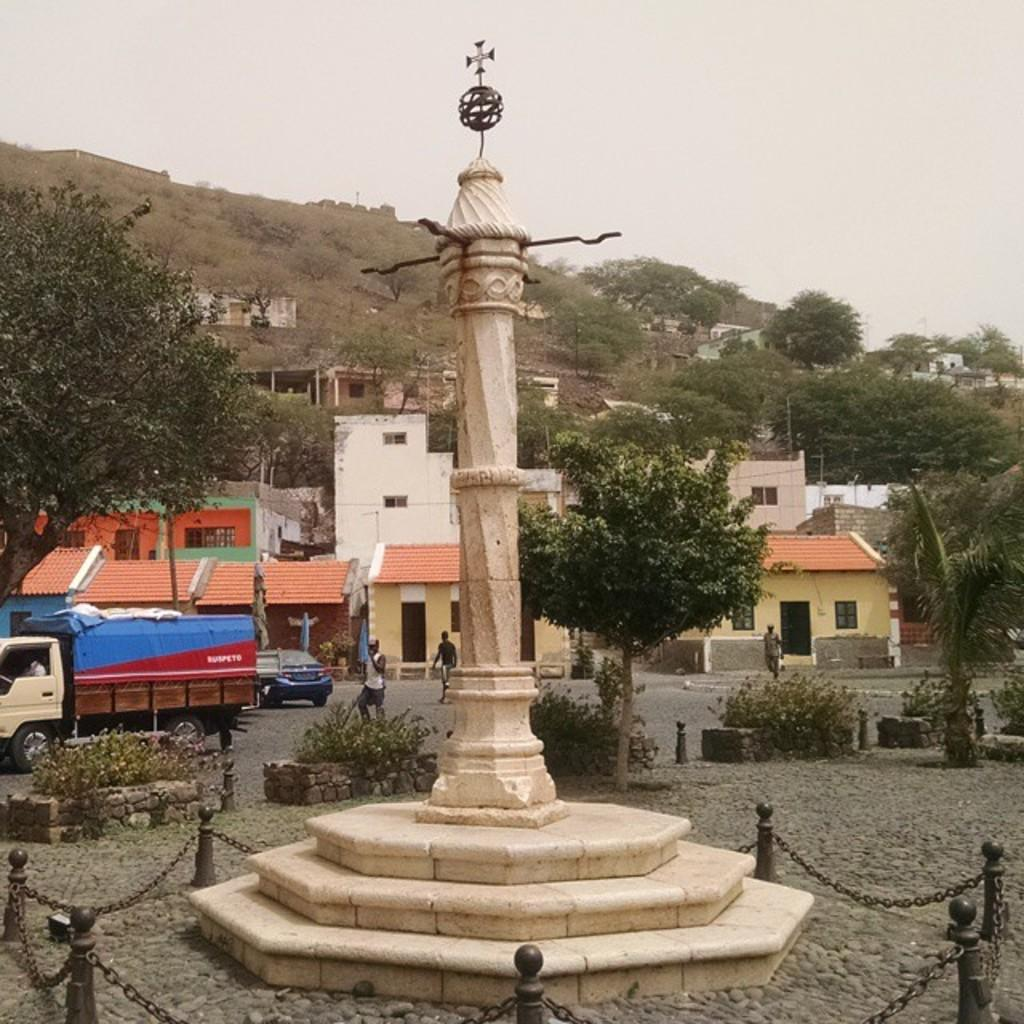What is the main structure in the center of the image? There is a tower in the center of the image. What can be seen on the left side of the image? There are vehicles on the left side of the image. What is visible in the background of the image? There are buildings and trees in the background of the image. What type of drug is being processed in the image? There is no drug or process visible in the image; it features a tower, vehicles, buildings, and trees. 